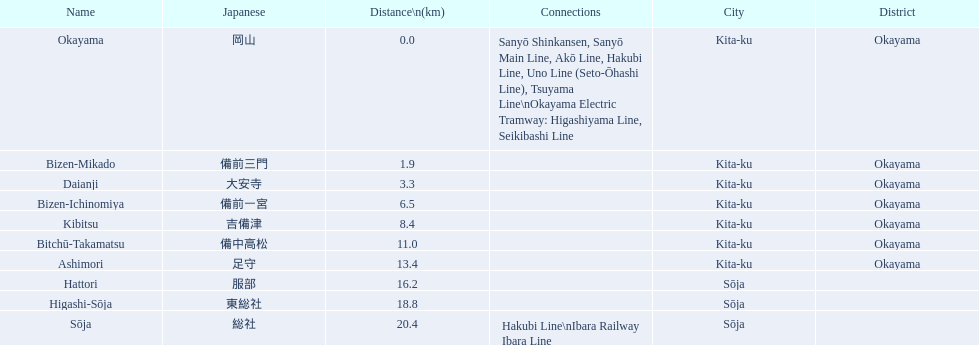What are all of the train names? Okayama, Bizen-Mikado, Daianji, Bizen-Ichinomiya, Kibitsu, Bitchū-Takamatsu, Ashimori, Hattori, Higashi-Sōja, Sōja. What is the distance for each? 0.0, 1.9, 3.3, 6.5, 8.4, 11.0, 13.4, 16.2, 18.8, 20.4. And which train's distance is between 1 and 2 km? Bizen-Mikado. 